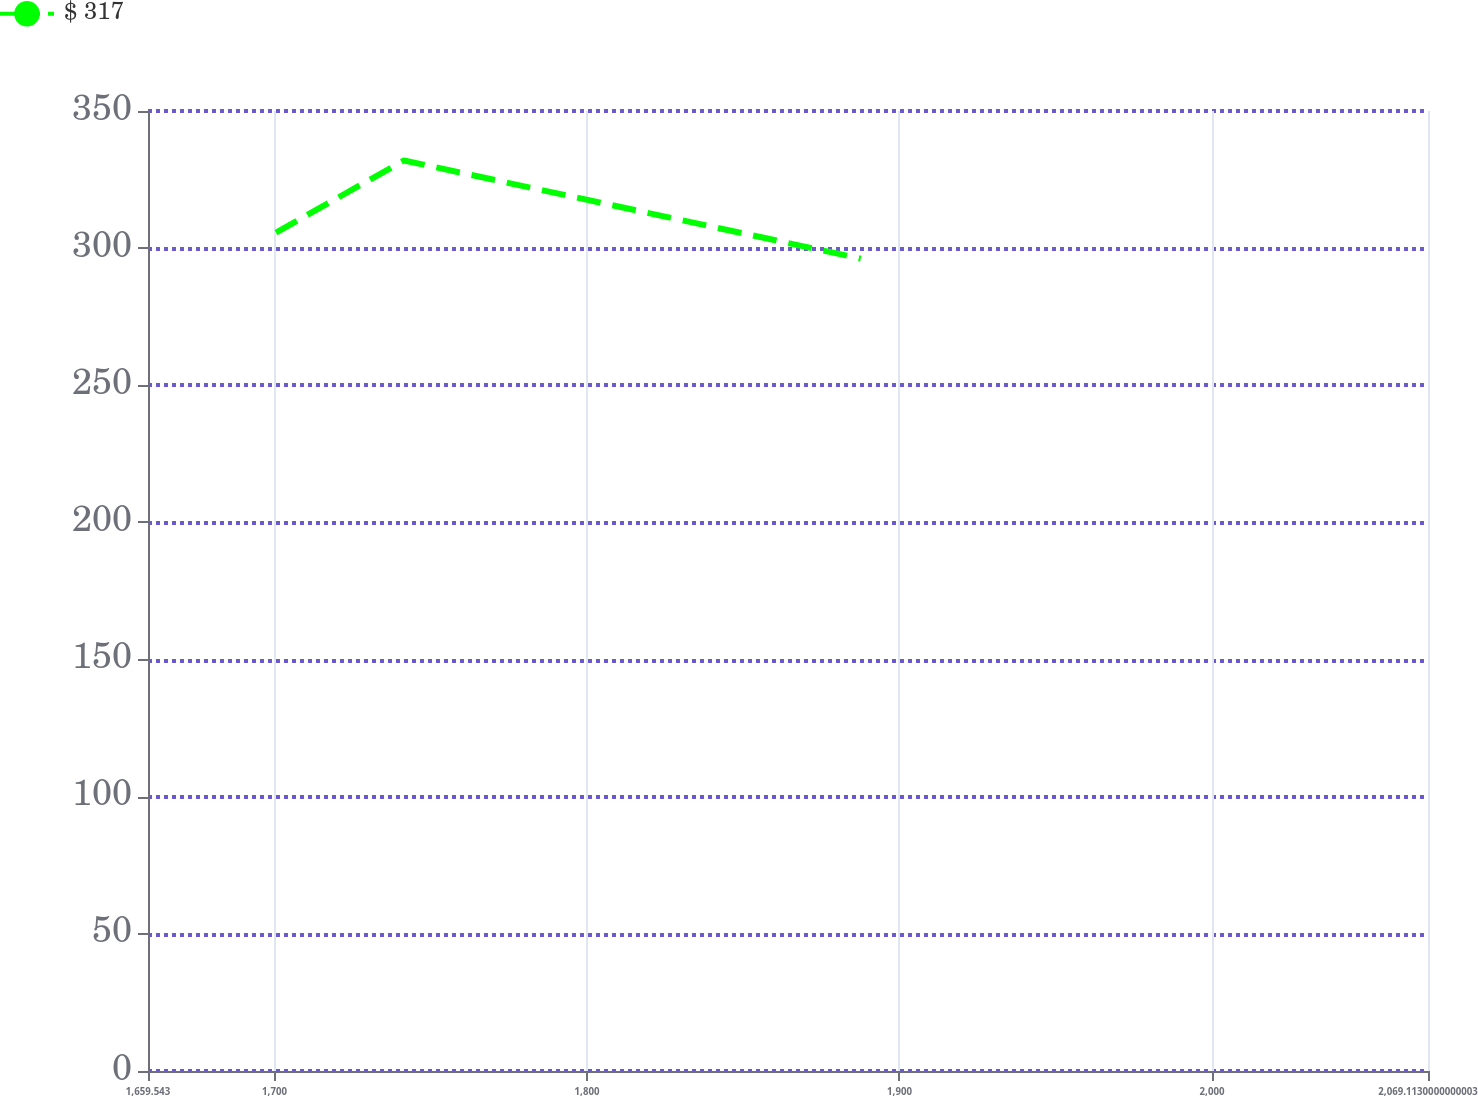<chart> <loc_0><loc_0><loc_500><loc_500><line_chart><ecel><fcel>$ 317<nl><fcel>1700.5<fcel>305.67<nl><fcel>1741.46<fcel>331.96<nl><fcel>1887.61<fcel>296.17<nl><fcel>2110.07<fcel>300.18<nl></chart> 